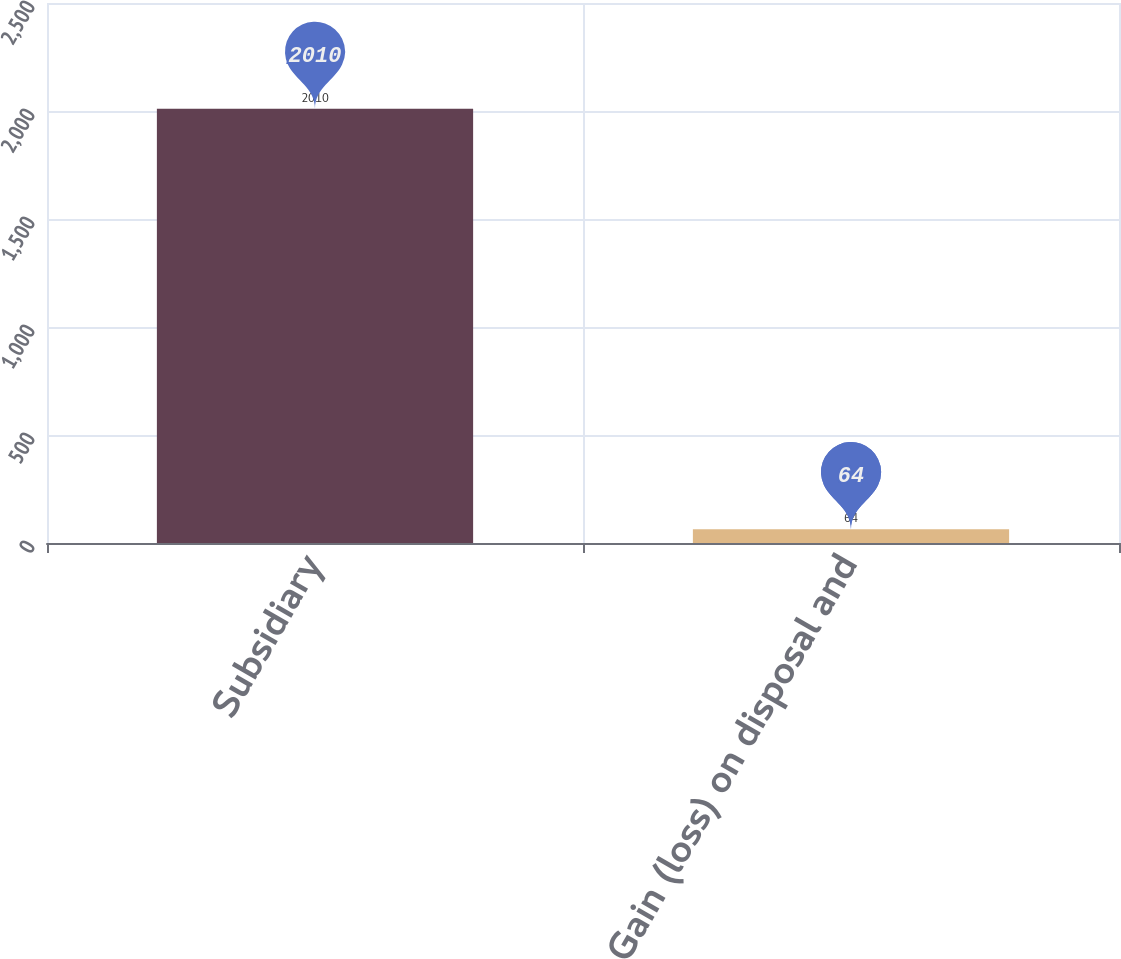Convert chart. <chart><loc_0><loc_0><loc_500><loc_500><bar_chart><fcel>Subsidiary<fcel>Gain (loss) on disposal and<nl><fcel>2010<fcel>64<nl></chart> 